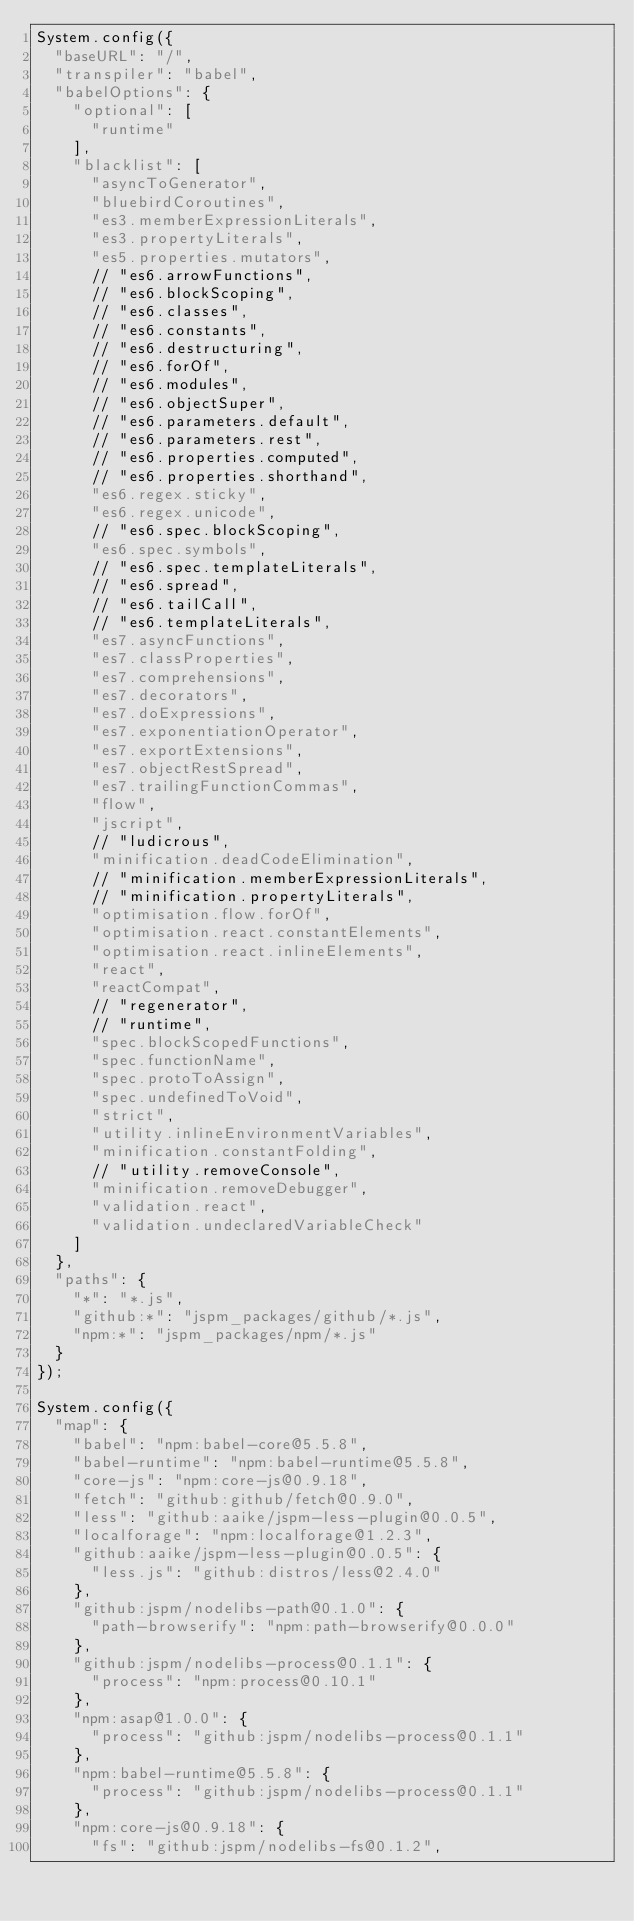<code> <loc_0><loc_0><loc_500><loc_500><_JavaScript_>System.config({
  "baseURL": "/",
  "transpiler": "babel",
  "babelOptions": {
    "optional": [
      "runtime"
    ],
    "blacklist": [
      "asyncToGenerator",
      "bluebirdCoroutines",
      "es3.memberExpressionLiterals",
      "es3.propertyLiterals",
      "es5.properties.mutators",
      // "es6.arrowFunctions",
      // "es6.blockScoping",
      // "es6.classes",
      // "es6.constants",
      // "es6.destructuring",
      // "es6.forOf",
      // "es6.modules",
      // "es6.objectSuper",
      // "es6.parameters.default",
      // "es6.parameters.rest",
      // "es6.properties.computed",
      // "es6.properties.shorthand",
      "es6.regex.sticky",
      "es6.regex.unicode",
      // "es6.spec.blockScoping",
      "es6.spec.symbols",
      // "es6.spec.templateLiterals",
      // "es6.spread",
      // "es6.tailCall",
      // "es6.templateLiterals",
      "es7.asyncFunctions",
      "es7.classProperties",
      "es7.comprehensions",
      "es7.decorators",
      "es7.doExpressions",
      "es7.exponentiationOperator",
      "es7.exportExtensions",
      "es7.objectRestSpread",
      "es7.trailingFunctionCommas",
      "flow",
      "jscript",
      // "ludicrous",
      "minification.deadCodeElimination",
      // "minification.memberExpressionLiterals",
      // "minification.propertyLiterals",
      "optimisation.flow.forOf",
      "optimisation.react.constantElements",
      "optimisation.react.inlineElements",
      "react",
      "reactCompat",
      // "regenerator",
      // "runtime",
      "spec.blockScopedFunctions",
      "spec.functionName",
      "spec.protoToAssign",
      "spec.undefinedToVoid",
      "strict",
      "utility.inlineEnvironmentVariables",
      "minification.constantFolding",
      // "utility.removeConsole",
      "minification.removeDebugger",
      "validation.react",
      "validation.undeclaredVariableCheck"
    ]
  },
  "paths": {
    "*": "*.js",
    "github:*": "jspm_packages/github/*.js",
    "npm:*": "jspm_packages/npm/*.js"
  }
});

System.config({
  "map": {
    "babel": "npm:babel-core@5.5.8",
    "babel-runtime": "npm:babel-runtime@5.5.8",
    "core-js": "npm:core-js@0.9.18",
    "fetch": "github:github/fetch@0.9.0",
    "less": "github:aaike/jspm-less-plugin@0.0.5",
    "localforage": "npm:localforage@1.2.3",
    "github:aaike/jspm-less-plugin@0.0.5": {
      "less.js": "github:distros/less@2.4.0"
    },
    "github:jspm/nodelibs-path@0.1.0": {
      "path-browserify": "npm:path-browserify@0.0.0"
    },
    "github:jspm/nodelibs-process@0.1.1": {
      "process": "npm:process@0.10.1"
    },
    "npm:asap@1.0.0": {
      "process": "github:jspm/nodelibs-process@0.1.1"
    },
    "npm:babel-runtime@5.5.8": {
      "process": "github:jspm/nodelibs-process@0.1.1"
    },
    "npm:core-js@0.9.18": {
      "fs": "github:jspm/nodelibs-fs@0.1.2",</code> 